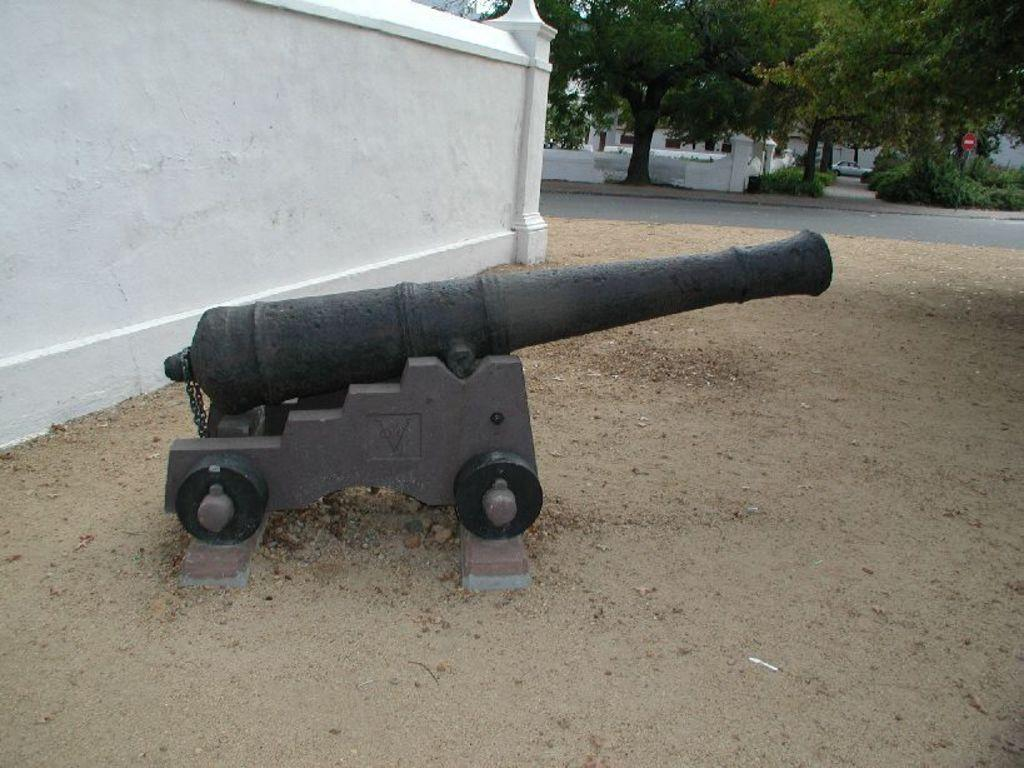What type of weapon is in the image? There is an old machine gun in the image. Where is the machine gun located? The machine gun is kept in front of a wall. What can be seen in the background of the image? There are trees and a caution board visible in the background. Can you describe the location of the caution board? The caution board is behind a road in the background. How many basketballs can be seen near the machine gun in the image? There are no basketballs present in the image. Can you describe the frog's behavior near the caution board in the image? There is no frog present in the image. 